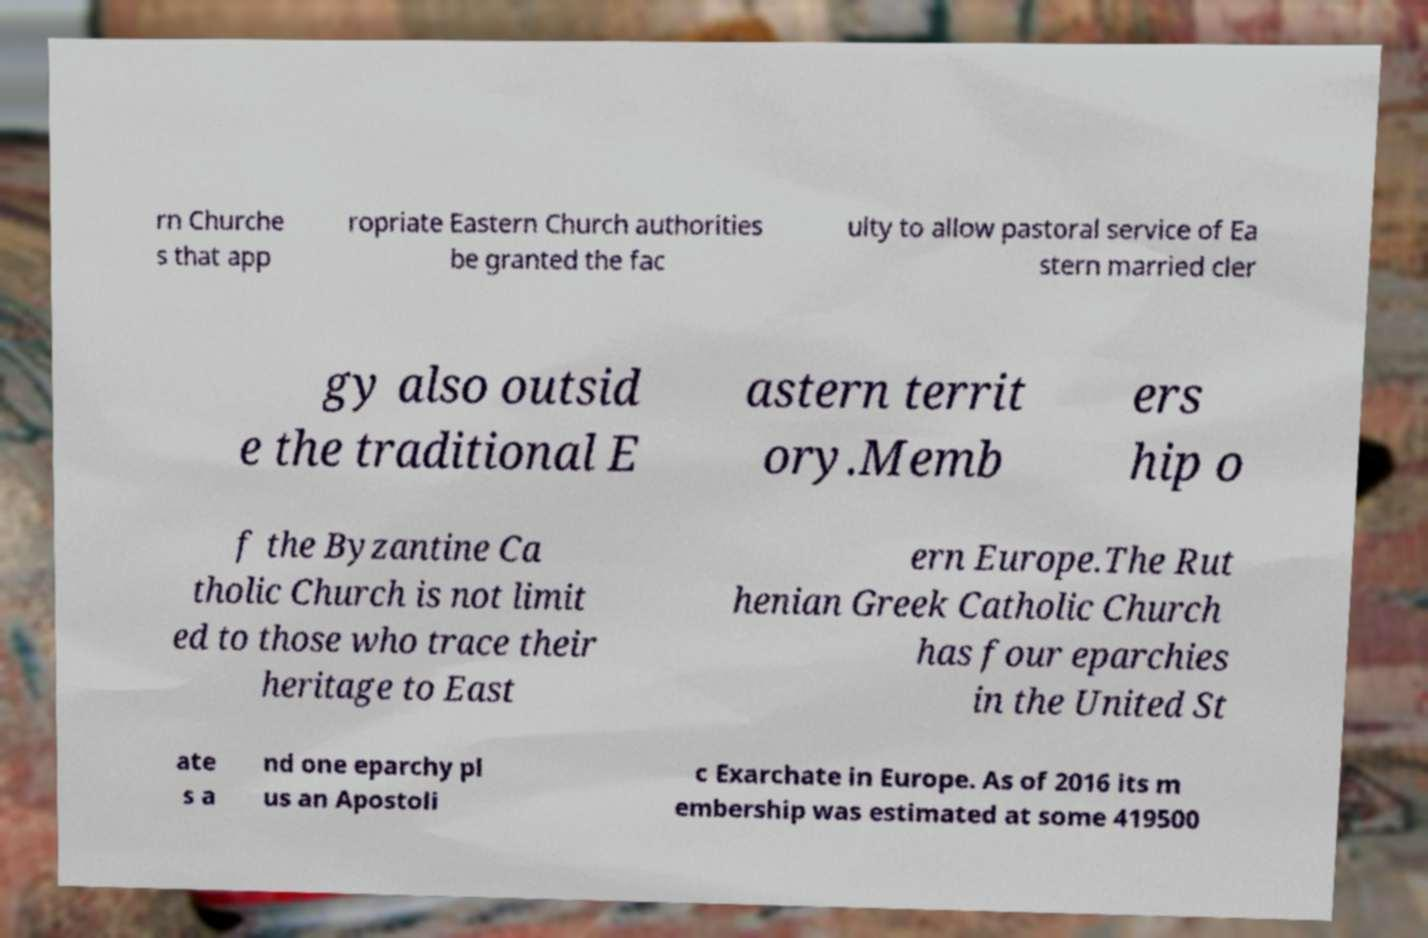Could you extract and type out the text from this image? rn Churche s that app ropriate Eastern Church authorities be granted the fac ulty to allow pastoral service of Ea stern married cler gy also outsid e the traditional E astern territ ory.Memb ers hip o f the Byzantine Ca tholic Church is not limit ed to those who trace their heritage to East ern Europe.The Rut henian Greek Catholic Church has four eparchies in the United St ate s a nd one eparchy pl us an Apostoli c Exarchate in Europe. As of 2016 its m embership was estimated at some 419500 